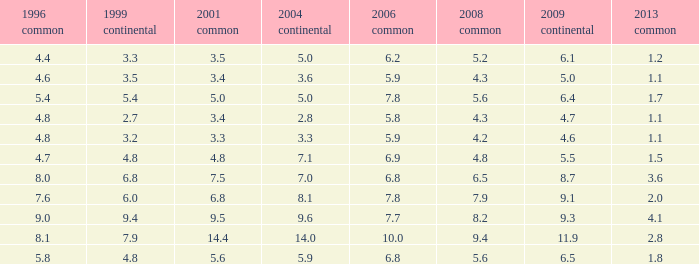What is the highest value for general 2008 when there is less than 5.5 in European 2009, more than 5.8 in general 2006, more than 3.3 in general 2001, and less than 3.6 for 2004 European? None. 